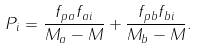<formula> <loc_0><loc_0><loc_500><loc_500>P _ { i } = \frac { f _ { p a } f _ { a i } } { M _ { a } - M } + \frac { f _ { p b } f _ { b i } } { M _ { b } - M } .</formula> 